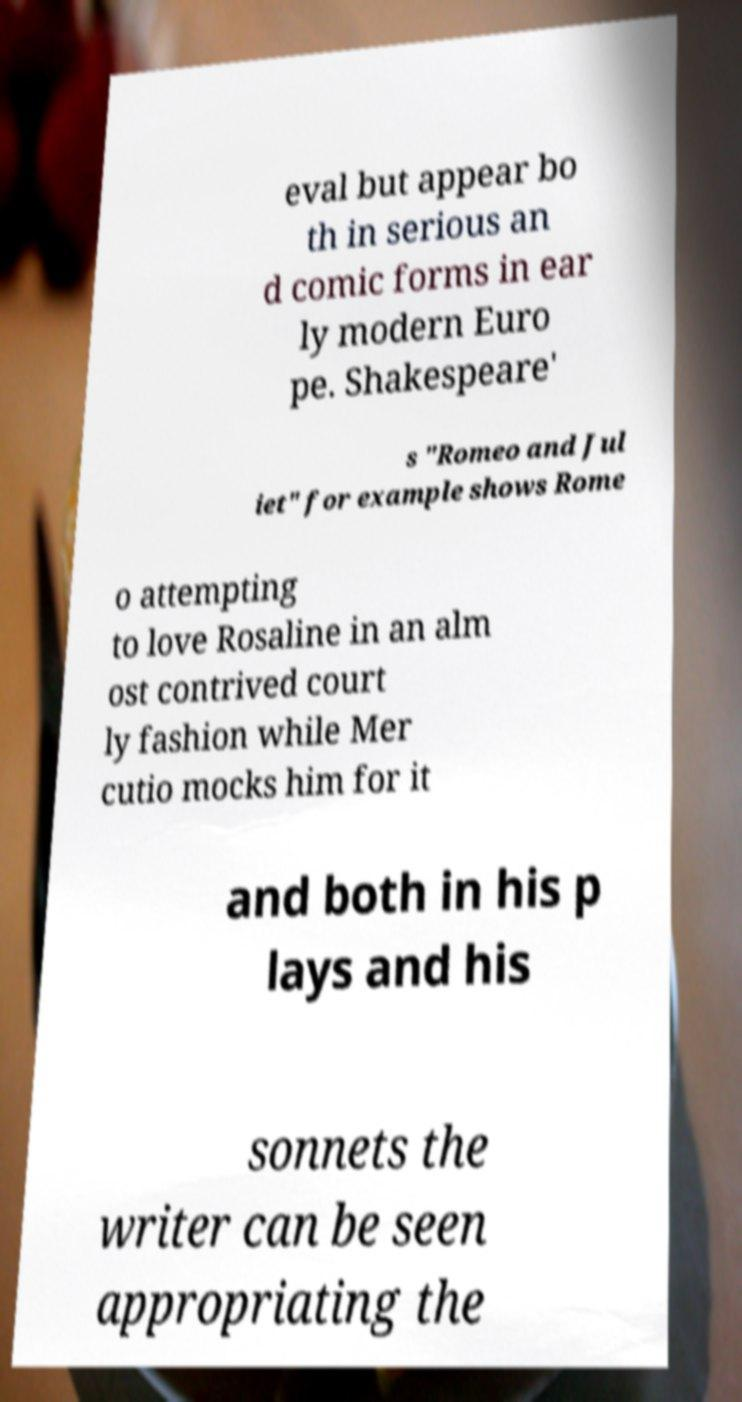Please read and relay the text visible in this image. What does it say? eval but appear bo th in serious an d comic forms in ear ly modern Euro pe. Shakespeare' s "Romeo and Jul iet" for example shows Rome o attempting to love Rosaline in an alm ost contrived court ly fashion while Mer cutio mocks him for it and both in his p lays and his sonnets the writer can be seen appropriating the 